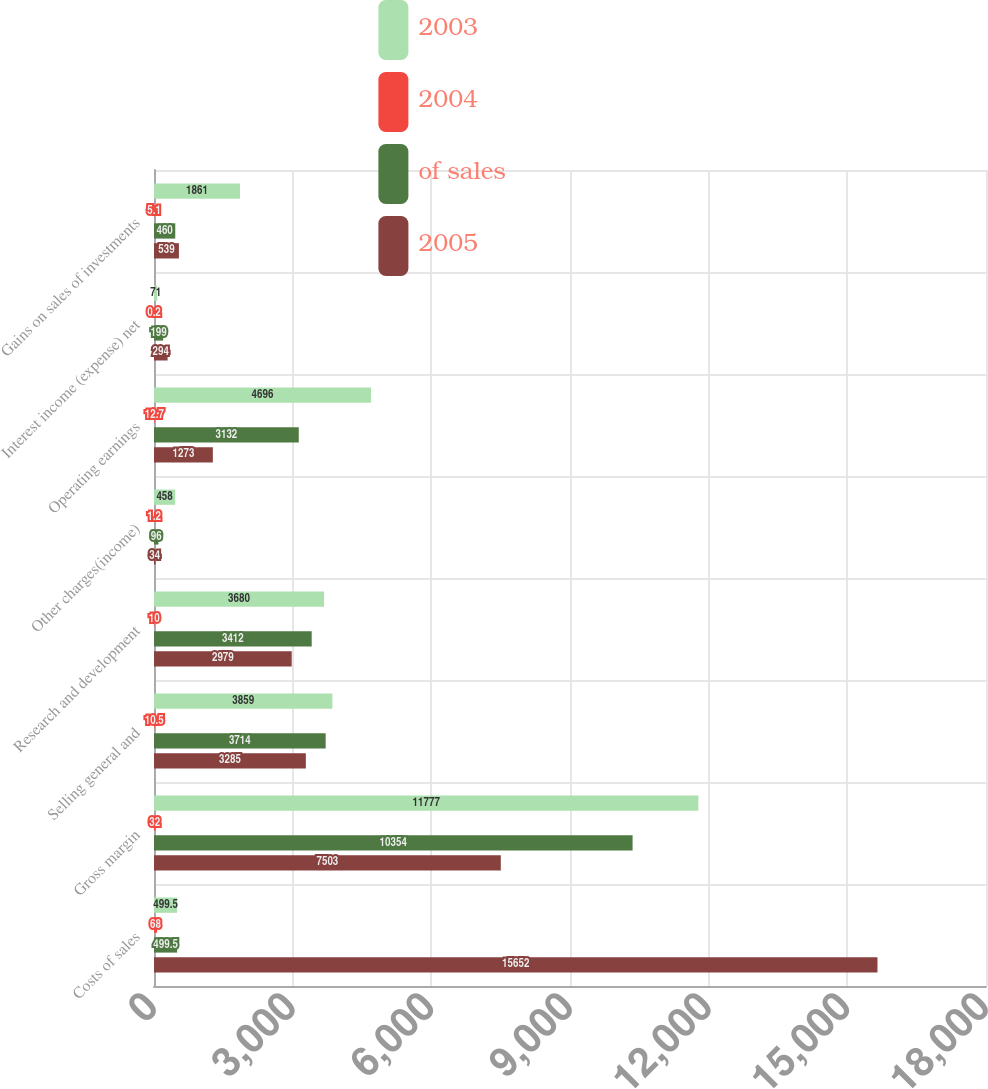Convert chart to OTSL. <chart><loc_0><loc_0><loc_500><loc_500><stacked_bar_chart><ecel><fcel>Costs of sales<fcel>Gross margin<fcel>Selling general and<fcel>Research and development<fcel>Other charges(income)<fcel>Operating earnings<fcel>Interest income (expense) net<fcel>Gains on sales of investments<nl><fcel>2003<fcel>499.5<fcel>11777<fcel>3859<fcel>3680<fcel>458<fcel>4696<fcel>71<fcel>1861<nl><fcel>2004<fcel>68<fcel>32<fcel>10.5<fcel>10<fcel>1.2<fcel>12.7<fcel>0.2<fcel>5.1<nl><fcel>of sales<fcel>499.5<fcel>10354<fcel>3714<fcel>3412<fcel>96<fcel>3132<fcel>199<fcel>460<nl><fcel>2005<fcel>15652<fcel>7503<fcel>3285<fcel>2979<fcel>34<fcel>1273<fcel>294<fcel>539<nl></chart> 